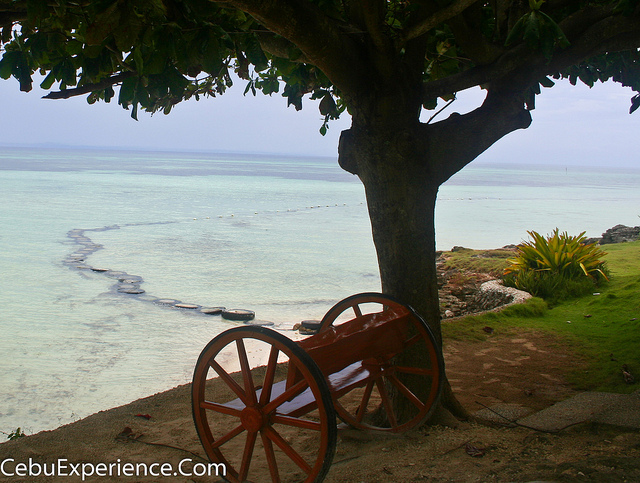Please transcribe the text information in this image. CebuExperience.Com 